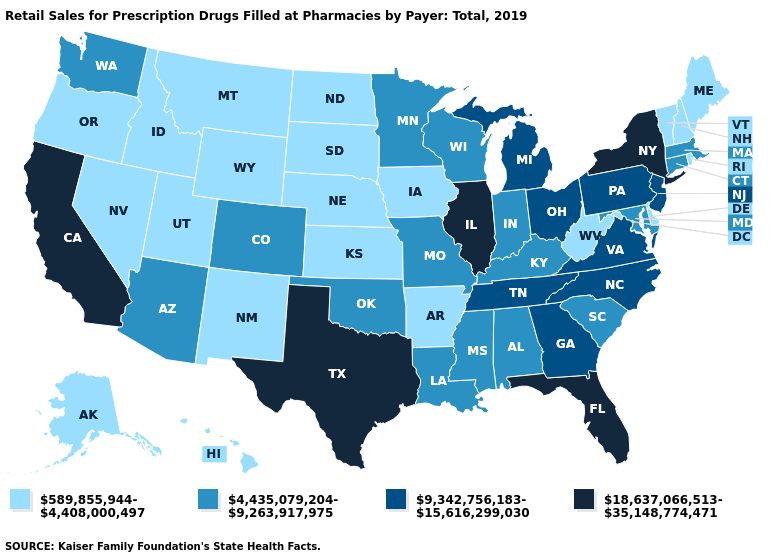What is the value of Mississippi?
Answer briefly. 4,435,079,204-9,263,917,975. What is the lowest value in states that border Iowa?
Keep it brief. 589,855,944-4,408,000,497. What is the highest value in the Northeast ?
Short answer required. 18,637,066,513-35,148,774,471. Among the states that border New Jersey , which have the highest value?
Quick response, please. New York. Name the states that have a value in the range 18,637,066,513-35,148,774,471?
Keep it brief. California, Florida, Illinois, New York, Texas. Does Florida have the highest value in the USA?
Concise answer only. Yes. What is the lowest value in the West?
Write a very short answer. 589,855,944-4,408,000,497. What is the lowest value in states that border Nebraska?
Answer briefly. 589,855,944-4,408,000,497. What is the value of New Hampshire?
Quick response, please. 589,855,944-4,408,000,497. Name the states that have a value in the range 18,637,066,513-35,148,774,471?
Keep it brief. California, Florida, Illinois, New York, Texas. Among the states that border Virginia , which have the highest value?
Give a very brief answer. North Carolina, Tennessee. What is the highest value in the West ?
Concise answer only. 18,637,066,513-35,148,774,471. Name the states that have a value in the range 589,855,944-4,408,000,497?
Write a very short answer. Alaska, Arkansas, Delaware, Hawaii, Idaho, Iowa, Kansas, Maine, Montana, Nebraska, Nevada, New Hampshire, New Mexico, North Dakota, Oregon, Rhode Island, South Dakota, Utah, Vermont, West Virginia, Wyoming. What is the value of Missouri?
Short answer required. 4,435,079,204-9,263,917,975. What is the value of South Dakota?
Concise answer only. 589,855,944-4,408,000,497. 